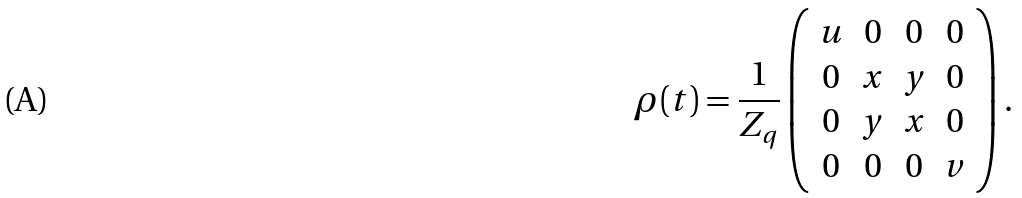<formula> <loc_0><loc_0><loc_500><loc_500>\rho ( t ) = \frac { 1 } { Z _ { q } } \left ( \begin{array} { c c c c } u & 0 & 0 & 0 \\ 0 & x & y & 0 \\ 0 & y & x & 0 \\ 0 & 0 & 0 & v \end{array} \right ) .</formula> 